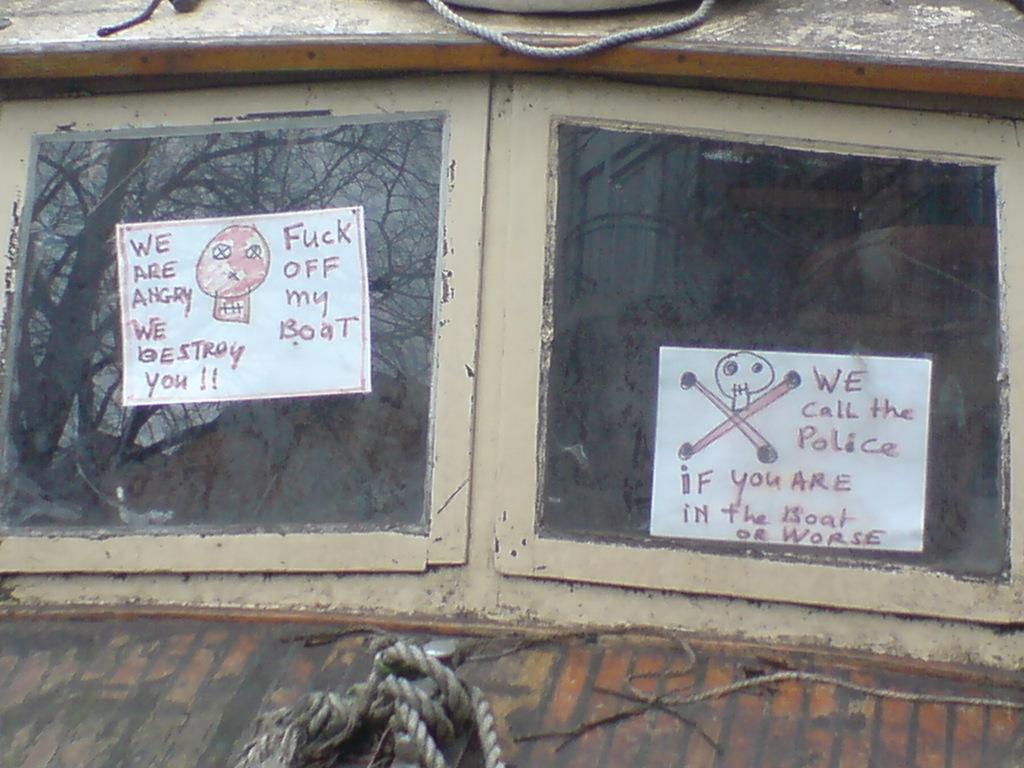Please provide a concise description of this image. In the center of the picture there are windows, on the windows there are papers stocked. At the bottom there are tapes. At the top there is a rope. 